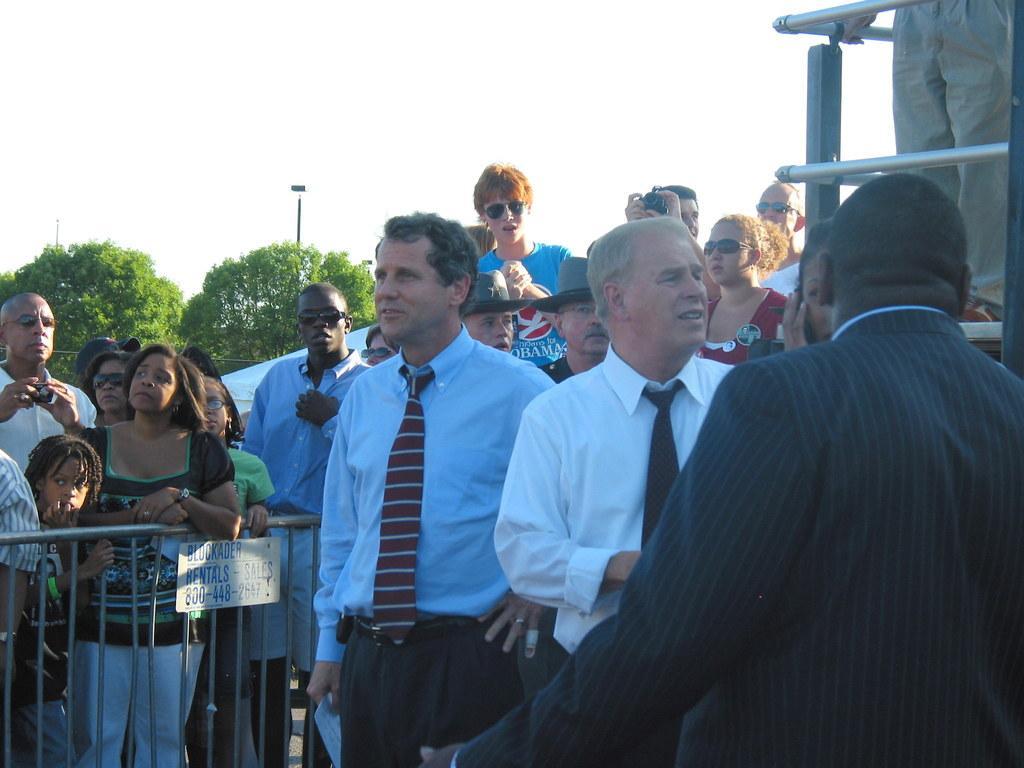In one or two sentences, can you explain what this image depicts? In this image I can see people standing. There is a fence on the left. There is a railing on the right. There is a pole and trees at the back. 